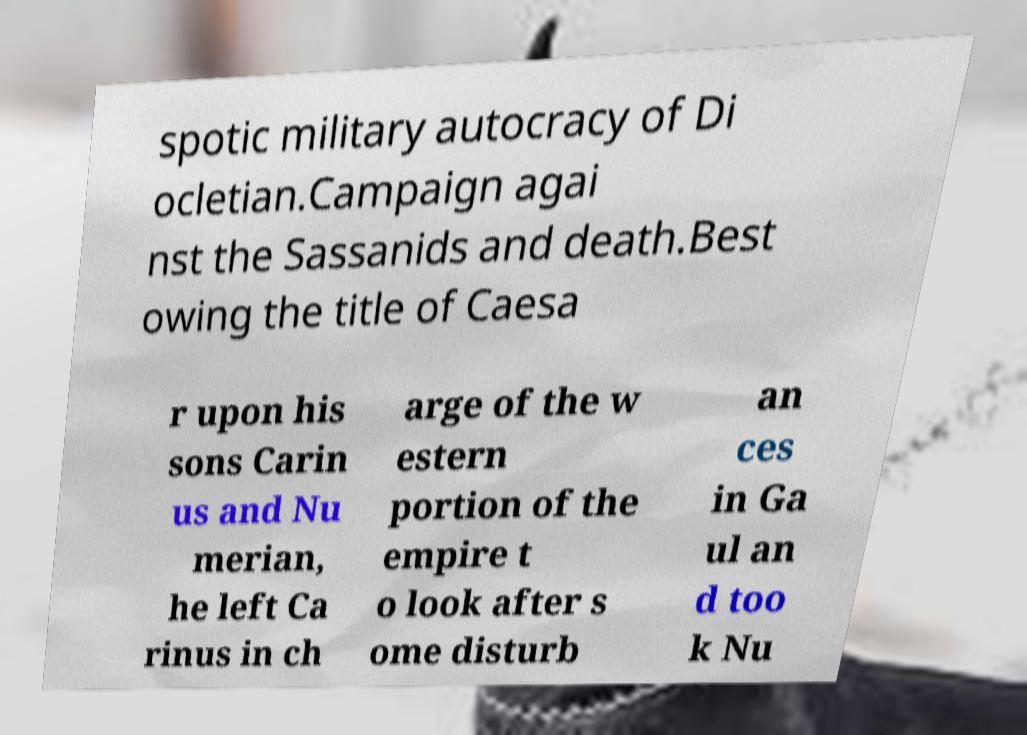For documentation purposes, I need the text within this image transcribed. Could you provide that? spotic military autocracy of Di ocletian.Campaign agai nst the Sassanids and death.Best owing the title of Caesa r upon his sons Carin us and Nu merian, he left Ca rinus in ch arge of the w estern portion of the empire t o look after s ome disturb an ces in Ga ul an d too k Nu 